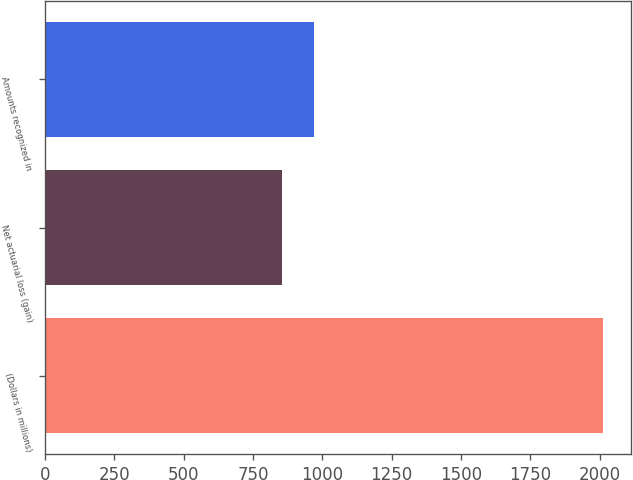Convert chart to OTSL. <chart><loc_0><loc_0><loc_500><loc_500><bar_chart><fcel>(Dollars in millions)<fcel>Net actuarial loss (gain)<fcel>Amounts recognized in<nl><fcel>2013<fcel>855<fcel>970.8<nl></chart> 